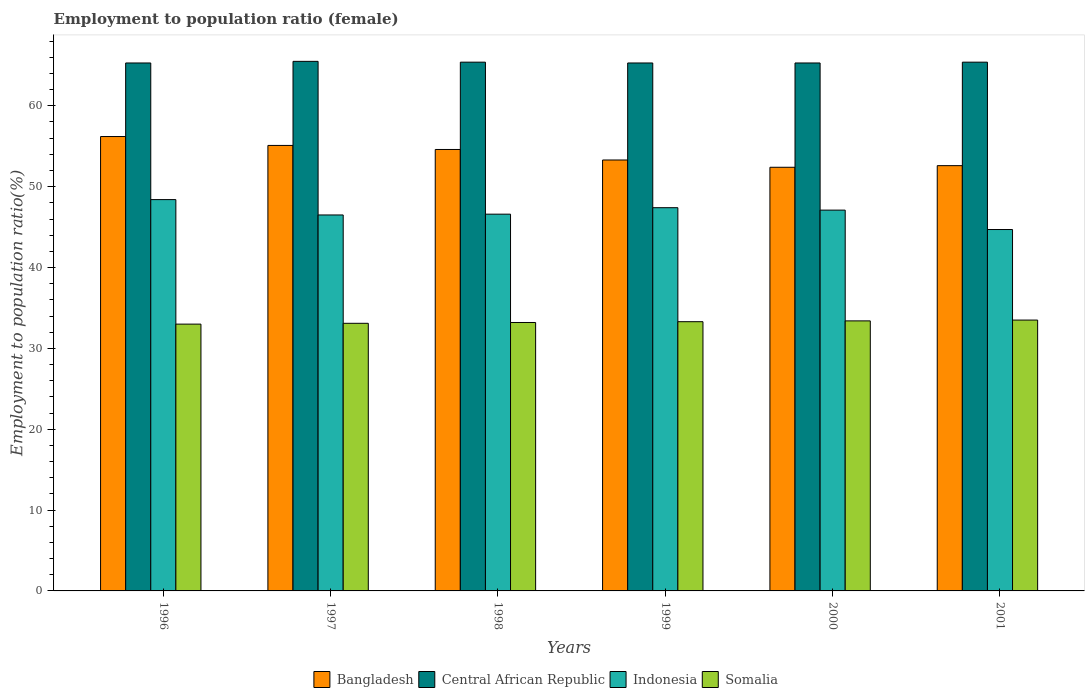How many different coloured bars are there?
Offer a terse response. 4. Are the number of bars on each tick of the X-axis equal?
Make the answer very short. Yes. How many bars are there on the 5th tick from the left?
Provide a succinct answer. 4. What is the employment to population ratio in Indonesia in 1998?
Offer a very short reply. 46.6. Across all years, what is the maximum employment to population ratio in Indonesia?
Offer a very short reply. 48.4. Across all years, what is the minimum employment to population ratio in Indonesia?
Provide a succinct answer. 44.7. In which year was the employment to population ratio in Somalia maximum?
Ensure brevity in your answer.  2001. In which year was the employment to population ratio in Bangladesh minimum?
Ensure brevity in your answer.  2000. What is the total employment to population ratio in Somalia in the graph?
Keep it short and to the point. 199.5. What is the difference between the employment to population ratio in Somalia in 1997 and that in 2000?
Your answer should be very brief. -0.3. What is the difference between the employment to population ratio in Indonesia in 1997 and the employment to population ratio in Bangladesh in 1998?
Keep it short and to the point. -8.1. What is the average employment to population ratio in Central African Republic per year?
Your response must be concise. 65.37. In the year 1997, what is the difference between the employment to population ratio in Bangladesh and employment to population ratio in Central African Republic?
Give a very brief answer. -10.4. What is the ratio of the employment to population ratio in Indonesia in 1998 to that in 2001?
Ensure brevity in your answer.  1.04. Is the employment to population ratio in Somalia in 2000 less than that in 2001?
Keep it short and to the point. Yes. What is the difference between the highest and the second highest employment to population ratio in Bangladesh?
Make the answer very short. 1.1. What is the difference between the highest and the lowest employment to population ratio in Somalia?
Offer a very short reply. 0.5. In how many years, is the employment to population ratio in Central African Republic greater than the average employment to population ratio in Central African Republic taken over all years?
Offer a terse response. 3. Is the sum of the employment to population ratio in Indonesia in 1997 and 1999 greater than the maximum employment to population ratio in Central African Republic across all years?
Offer a very short reply. Yes. What does the 3rd bar from the right in 1998 represents?
Your answer should be very brief. Central African Republic. Is it the case that in every year, the sum of the employment to population ratio in Indonesia and employment to population ratio in Somalia is greater than the employment to population ratio in Bangladesh?
Make the answer very short. Yes. Are all the bars in the graph horizontal?
Ensure brevity in your answer.  No. How many years are there in the graph?
Keep it short and to the point. 6. Where does the legend appear in the graph?
Your answer should be very brief. Bottom center. What is the title of the graph?
Provide a short and direct response. Employment to population ratio (female). Does "Latvia" appear as one of the legend labels in the graph?
Offer a terse response. No. What is the label or title of the Y-axis?
Ensure brevity in your answer.  Employment to population ratio(%). What is the Employment to population ratio(%) in Bangladesh in 1996?
Your response must be concise. 56.2. What is the Employment to population ratio(%) in Central African Republic in 1996?
Your response must be concise. 65.3. What is the Employment to population ratio(%) in Indonesia in 1996?
Provide a short and direct response. 48.4. What is the Employment to population ratio(%) of Somalia in 1996?
Offer a very short reply. 33. What is the Employment to population ratio(%) in Bangladesh in 1997?
Keep it short and to the point. 55.1. What is the Employment to population ratio(%) of Central African Republic in 1997?
Give a very brief answer. 65.5. What is the Employment to population ratio(%) in Indonesia in 1997?
Offer a terse response. 46.5. What is the Employment to population ratio(%) of Somalia in 1997?
Provide a succinct answer. 33.1. What is the Employment to population ratio(%) of Bangladesh in 1998?
Give a very brief answer. 54.6. What is the Employment to population ratio(%) in Central African Republic in 1998?
Make the answer very short. 65.4. What is the Employment to population ratio(%) of Indonesia in 1998?
Your answer should be very brief. 46.6. What is the Employment to population ratio(%) of Somalia in 1998?
Ensure brevity in your answer.  33.2. What is the Employment to population ratio(%) of Bangladesh in 1999?
Your answer should be compact. 53.3. What is the Employment to population ratio(%) in Central African Republic in 1999?
Your answer should be very brief. 65.3. What is the Employment to population ratio(%) of Indonesia in 1999?
Your response must be concise. 47.4. What is the Employment to population ratio(%) of Somalia in 1999?
Your response must be concise. 33.3. What is the Employment to population ratio(%) of Bangladesh in 2000?
Your answer should be compact. 52.4. What is the Employment to population ratio(%) of Central African Republic in 2000?
Provide a succinct answer. 65.3. What is the Employment to population ratio(%) in Indonesia in 2000?
Provide a succinct answer. 47.1. What is the Employment to population ratio(%) of Somalia in 2000?
Your answer should be very brief. 33.4. What is the Employment to population ratio(%) of Bangladesh in 2001?
Keep it short and to the point. 52.6. What is the Employment to population ratio(%) of Central African Republic in 2001?
Make the answer very short. 65.4. What is the Employment to population ratio(%) of Indonesia in 2001?
Your response must be concise. 44.7. What is the Employment to population ratio(%) of Somalia in 2001?
Your response must be concise. 33.5. Across all years, what is the maximum Employment to population ratio(%) of Bangladesh?
Make the answer very short. 56.2. Across all years, what is the maximum Employment to population ratio(%) of Central African Republic?
Your answer should be very brief. 65.5. Across all years, what is the maximum Employment to population ratio(%) in Indonesia?
Make the answer very short. 48.4. Across all years, what is the maximum Employment to population ratio(%) in Somalia?
Keep it short and to the point. 33.5. Across all years, what is the minimum Employment to population ratio(%) in Bangladesh?
Provide a succinct answer. 52.4. Across all years, what is the minimum Employment to population ratio(%) in Central African Republic?
Offer a very short reply. 65.3. Across all years, what is the minimum Employment to population ratio(%) of Indonesia?
Your answer should be very brief. 44.7. Across all years, what is the minimum Employment to population ratio(%) in Somalia?
Offer a terse response. 33. What is the total Employment to population ratio(%) of Bangladesh in the graph?
Offer a very short reply. 324.2. What is the total Employment to population ratio(%) in Central African Republic in the graph?
Make the answer very short. 392.2. What is the total Employment to population ratio(%) in Indonesia in the graph?
Give a very brief answer. 280.7. What is the total Employment to population ratio(%) of Somalia in the graph?
Offer a terse response. 199.5. What is the difference between the Employment to population ratio(%) of Bangladesh in 1996 and that in 1997?
Your answer should be very brief. 1.1. What is the difference between the Employment to population ratio(%) of Central African Republic in 1996 and that in 1997?
Provide a succinct answer. -0.2. What is the difference between the Employment to population ratio(%) in Indonesia in 1996 and that in 1997?
Your response must be concise. 1.9. What is the difference between the Employment to population ratio(%) in Bangladesh in 1996 and that in 1998?
Ensure brevity in your answer.  1.6. What is the difference between the Employment to population ratio(%) of Central African Republic in 1996 and that in 1998?
Give a very brief answer. -0.1. What is the difference between the Employment to population ratio(%) in Somalia in 1996 and that in 1998?
Offer a very short reply. -0.2. What is the difference between the Employment to population ratio(%) of Bangladesh in 1996 and that in 1999?
Offer a very short reply. 2.9. What is the difference between the Employment to population ratio(%) of Central African Republic in 1996 and that in 1999?
Make the answer very short. 0. What is the difference between the Employment to population ratio(%) of Indonesia in 1996 and that in 1999?
Give a very brief answer. 1. What is the difference between the Employment to population ratio(%) in Indonesia in 1996 and that in 2000?
Provide a succinct answer. 1.3. What is the difference between the Employment to population ratio(%) of Bangladesh in 1996 and that in 2001?
Give a very brief answer. 3.6. What is the difference between the Employment to population ratio(%) in Somalia in 1997 and that in 1998?
Keep it short and to the point. -0.1. What is the difference between the Employment to population ratio(%) of Bangladesh in 1997 and that in 1999?
Keep it short and to the point. 1.8. What is the difference between the Employment to population ratio(%) in Central African Republic in 1997 and that in 1999?
Offer a very short reply. 0.2. What is the difference between the Employment to population ratio(%) in Indonesia in 1997 and that in 1999?
Provide a short and direct response. -0.9. What is the difference between the Employment to population ratio(%) in Bangladesh in 1997 and that in 2001?
Your answer should be very brief. 2.5. What is the difference between the Employment to population ratio(%) in Bangladesh in 1998 and that in 1999?
Your answer should be compact. 1.3. What is the difference between the Employment to population ratio(%) of Central African Republic in 1998 and that in 1999?
Ensure brevity in your answer.  0.1. What is the difference between the Employment to population ratio(%) of Somalia in 1998 and that in 1999?
Your answer should be compact. -0.1. What is the difference between the Employment to population ratio(%) of Central African Republic in 1998 and that in 2000?
Your response must be concise. 0.1. What is the difference between the Employment to population ratio(%) in Indonesia in 1998 and that in 2000?
Offer a terse response. -0.5. What is the difference between the Employment to population ratio(%) in Bangladesh in 1998 and that in 2001?
Your response must be concise. 2. What is the difference between the Employment to population ratio(%) in Central African Republic in 1998 and that in 2001?
Provide a succinct answer. 0. What is the difference between the Employment to population ratio(%) of Central African Republic in 1999 and that in 2001?
Your answer should be very brief. -0.1. What is the difference between the Employment to population ratio(%) of Indonesia in 1999 and that in 2001?
Your answer should be very brief. 2.7. What is the difference between the Employment to population ratio(%) of Somalia in 1999 and that in 2001?
Provide a succinct answer. -0.2. What is the difference between the Employment to population ratio(%) of Central African Republic in 2000 and that in 2001?
Your response must be concise. -0.1. What is the difference between the Employment to population ratio(%) in Indonesia in 2000 and that in 2001?
Your response must be concise. 2.4. What is the difference between the Employment to population ratio(%) of Somalia in 2000 and that in 2001?
Your answer should be very brief. -0.1. What is the difference between the Employment to population ratio(%) in Bangladesh in 1996 and the Employment to population ratio(%) in Somalia in 1997?
Offer a very short reply. 23.1. What is the difference between the Employment to population ratio(%) of Central African Republic in 1996 and the Employment to population ratio(%) of Indonesia in 1997?
Give a very brief answer. 18.8. What is the difference between the Employment to population ratio(%) in Central African Republic in 1996 and the Employment to population ratio(%) in Somalia in 1997?
Your answer should be compact. 32.2. What is the difference between the Employment to population ratio(%) in Indonesia in 1996 and the Employment to population ratio(%) in Somalia in 1997?
Keep it short and to the point. 15.3. What is the difference between the Employment to population ratio(%) of Bangladesh in 1996 and the Employment to population ratio(%) of Central African Republic in 1998?
Give a very brief answer. -9.2. What is the difference between the Employment to population ratio(%) in Bangladesh in 1996 and the Employment to population ratio(%) in Indonesia in 1998?
Offer a terse response. 9.6. What is the difference between the Employment to population ratio(%) of Central African Republic in 1996 and the Employment to population ratio(%) of Somalia in 1998?
Your answer should be compact. 32.1. What is the difference between the Employment to population ratio(%) in Indonesia in 1996 and the Employment to population ratio(%) in Somalia in 1998?
Offer a terse response. 15.2. What is the difference between the Employment to population ratio(%) in Bangladesh in 1996 and the Employment to population ratio(%) in Central African Republic in 1999?
Ensure brevity in your answer.  -9.1. What is the difference between the Employment to population ratio(%) in Bangladesh in 1996 and the Employment to population ratio(%) in Indonesia in 1999?
Ensure brevity in your answer.  8.8. What is the difference between the Employment to population ratio(%) of Bangladesh in 1996 and the Employment to population ratio(%) of Somalia in 1999?
Provide a succinct answer. 22.9. What is the difference between the Employment to population ratio(%) in Central African Republic in 1996 and the Employment to population ratio(%) in Indonesia in 1999?
Keep it short and to the point. 17.9. What is the difference between the Employment to population ratio(%) of Bangladesh in 1996 and the Employment to population ratio(%) of Somalia in 2000?
Make the answer very short. 22.8. What is the difference between the Employment to population ratio(%) of Central African Republic in 1996 and the Employment to population ratio(%) of Somalia in 2000?
Provide a short and direct response. 31.9. What is the difference between the Employment to population ratio(%) in Indonesia in 1996 and the Employment to population ratio(%) in Somalia in 2000?
Your answer should be very brief. 15. What is the difference between the Employment to population ratio(%) in Bangladesh in 1996 and the Employment to population ratio(%) in Somalia in 2001?
Give a very brief answer. 22.7. What is the difference between the Employment to population ratio(%) in Central African Republic in 1996 and the Employment to population ratio(%) in Indonesia in 2001?
Provide a succinct answer. 20.6. What is the difference between the Employment to population ratio(%) of Central African Republic in 1996 and the Employment to population ratio(%) of Somalia in 2001?
Offer a very short reply. 31.8. What is the difference between the Employment to population ratio(%) in Indonesia in 1996 and the Employment to population ratio(%) in Somalia in 2001?
Your answer should be very brief. 14.9. What is the difference between the Employment to population ratio(%) of Bangladesh in 1997 and the Employment to population ratio(%) of Central African Republic in 1998?
Make the answer very short. -10.3. What is the difference between the Employment to population ratio(%) of Bangladesh in 1997 and the Employment to population ratio(%) of Somalia in 1998?
Provide a short and direct response. 21.9. What is the difference between the Employment to population ratio(%) in Central African Republic in 1997 and the Employment to population ratio(%) in Indonesia in 1998?
Your answer should be compact. 18.9. What is the difference between the Employment to population ratio(%) in Central African Republic in 1997 and the Employment to population ratio(%) in Somalia in 1998?
Keep it short and to the point. 32.3. What is the difference between the Employment to population ratio(%) of Bangladesh in 1997 and the Employment to population ratio(%) of Indonesia in 1999?
Keep it short and to the point. 7.7. What is the difference between the Employment to population ratio(%) of Bangladesh in 1997 and the Employment to population ratio(%) of Somalia in 1999?
Give a very brief answer. 21.8. What is the difference between the Employment to population ratio(%) in Central African Republic in 1997 and the Employment to population ratio(%) in Somalia in 1999?
Provide a succinct answer. 32.2. What is the difference between the Employment to population ratio(%) of Indonesia in 1997 and the Employment to population ratio(%) of Somalia in 1999?
Give a very brief answer. 13.2. What is the difference between the Employment to population ratio(%) of Bangladesh in 1997 and the Employment to population ratio(%) of Somalia in 2000?
Keep it short and to the point. 21.7. What is the difference between the Employment to population ratio(%) of Central African Republic in 1997 and the Employment to population ratio(%) of Indonesia in 2000?
Offer a very short reply. 18.4. What is the difference between the Employment to population ratio(%) in Central African Republic in 1997 and the Employment to population ratio(%) in Somalia in 2000?
Give a very brief answer. 32.1. What is the difference between the Employment to population ratio(%) of Bangladesh in 1997 and the Employment to population ratio(%) of Central African Republic in 2001?
Give a very brief answer. -10.3. What is the difference between the Employment to population ratio(%) of Bangladesh in 1997 and the Employment to population ratio(%) of Somalia in 2001?
Offer a very short reply. 21.6. What is the difference between the Employment to population ratio(%) of Central African Republic in 1997 and the Employment to population ratio(%) of Indonesia in 2001?
Offer a very short reply. 20.8. What is the difference between the Employment to population ratio(%) in Central African Republic in 1997 and the Employment to population ratio(%) in Somalia in 2001?
Offer a very short reply. 32. What is the difference between the Employment to population ratio(%) of Bangladesh in 1998 and the Employment to population ratio(%) of Central African Republic in 1999?
Your response must be concise. -10.7. What is the difference between the Employment to population ratio(%) in Bangladesh in 1998 and the Employment to population ratio(%) in Indonesia in 1999?
Offer a very short reply. 7.2. What is the difference between the Employment to population ratio(%) in Bangladesh in 1998 and the Employment to population ratio(%) in Somalia in 1999?
Provide a short and direct response. 21.3. What is the difference between the Employment to population ratio(%) of Central African Republic in 1998 and the Employment to population ratio(%) of Indonesia in 1999?
Your response must be concise. 18. What is the difference between the Employment to population ratio(%) of Central African Republic in 1998 and the Employment to population ratio(%) of Somalia in 1999?
Your response must be concise. 32.1. What is the difference between the Employment to population ratio(%) of Indonesia in 1998 and the Employment to population ratio(%) of Somalia in 1999?
Give a very brief answer. 13.3. What is the difference between the Employment to population ratio(%) in Bangladesh in 1998 and the Employment to population ratio(%) in Central African Republic in 2000?
Provide a succinct answer. -10.7. What is the difference between the Employment to population ratio(%) of Bangladesh in 1998 and the Employment to population ratio(%) of Somalia in 2000?
Provide a short and direct response. 21.2. What is the difference between the Employment to population ratio(%) of Central African Republic in 1998 and the Employment to population ratio(%) of Indonesia in 2000?
Provide a succinct answer. 18.3. What is the difference between the Employment to population ratio(%) in Bangladesh in 1998 and the Employment to population ratio(%) in Somalia in 2001?
Your answer should be compact. 21.1. What is the difference between the Employment to population ratio(%) of Central African Republic in 1998 and the Employment to population ratio(%) of Indonesia in 2001?
Ensure brevity in your answer.  20.7. What is the difference between the Employment to population ratio(%) in Central African Republic in 1998 and the Employment to population ratio(%) in Somalia in 2001?
Offer a very short reply. 31.9. What is the difference between the Employment to population ratio(%) of Indonesia in 1998 and the Employment to population ratio(%) of Somalia in 2001?
Provide a short and direct response. 13.1. What is the difference between the Employment to population ratio(%) of Bangladesh in 1999 and the Employment to population ratio(%) of Central African Republic in 2000?
Offer a very short reply. -12. What is the difference between the Employment to population ratio(%) in Central African Republic in 1999 and the Employment to population ratio(%) in Somalia in 2000?
Keep it short and to the point. 31.9. What is the difference between the Employment to population ratio(%) of Indonesia in 1999 and the Employment to population ratio(%) of Somalia in 2000?
Your response must be concise. 14. What is the difference between the Employment to population ratio(%) in Bangladesh in 1999 and the Employment to population ratio(%) in Indonesia in 2001?
Give a very brief answer. 8.6. What is the difference between the Employment to population ratio(%) of Bangladesh in 1999 and the Employment to population ratio(%) of Somalia in 2001?
Keep it short and to the point. 19.8. What is the difference between the Employment to population ratio(%) in Central African Republic in 1999 and the Employment to population ratio(%) in Indonesia in 2001?
Give a very brief answer. 20.6. What is the difference between the Employment to population ratio(%) of Central African Republic in 1999 and the Employment to population ratio(%) of Somalia in 2001?
Offer a very short reply. 31.8. What is the difference between the Employment to population ratio(%) in Indonesia in 1999 and the Employment to population ratio(%) in Somalia in 2001?
Offer a very short reply. 13.9. What is the difference between the Employment to population ratio(%) in Central African Republic in 2000 and the Employment to population ratio(%) in Indonesia in 2001?
Offer a very short reply. 20.6. What is the difference between the Employment to population ratio(%) of Central African Republic in 2000 and the Employment to population ratio(%) of Somalia in 2001?
Give a very brief answer. 31.8. What is the average Employment to population ratio(%) in Bangladesh per year?
Give a very brief answer. 54.03. What is the average Employment to population ratio(%) of Central African Republic per year?
Provide a short and direct response. 65.37. What is the average Employment to population ratio(%) of Indonesia per year?
Provide a short and direct response. 46.78. What is the average Employment to population ratio(%) in Somalia per year?
Make the answer very short. 33.25. In the year 1996, what is the difference between the Employment to population ratio(%) in Bangladesh and Employment to population ratio(%) in Somalia?
Keep it short and to the point. 23.2. In the year 1996, what is the difference between the Employment to population ratio(%) in Central African Republic and Employment to population ratio(%) in Indonesia?
Your response must be concise. 16.9. In the year 1996, what is the difference between the Employment to population ratio(%) of Central African Republic and Employment to population ratio(%) of Somalia?
Give a very brief answer. 32.3. In the year 1997, what is the difference between the Employment to population ratio(%) of Bangladesh and Employment to population ratio(%) of Central African Republic?
Your answer should be compact. -10.4. In the year 1997, what is the difference between the Employment to population ratio(%) in Bangladesh and Employment to population ratio(%) in Indonesia?
Your answer should be very brief. 8.6. In the year 1997, what is the difference between the Employment to population ratio(%) in Bangladesh and Employment to population ratio(%) in Somalia?
Keep it short and to the point. 22. In the year 1997, what is the difference between the Employment to population ratio(%) of Central African Republic and Employment to population ratio(%) of Somalia?
Offer a very short reply. 32.4. In the year 1997, what is the difference between the Employment to population ratio(%) in Indonesia and Employment to population ratio(%) in Somalia?
Ensure brevity in your answer.  13.4. In the year 1998, what is the difference between the Employment to population ratio(%) in Bangladesh and Employment to population ratio(%) in Indonesia?
Give a very brief answer. 8. In the year 1998, what is the difference between the Employment to population ratio(%) of Bangladesh and Employment to population ratio(%) of Somalia?
Give a very brief answer. 21.4. In the year 1998, what is the difference between the Employment to population ratio(%) in Central African Republic and Employment to population ratio(%) in Somalia?
Offer a very short reply. 32.2. In the year 1999, what is the difference between the Employment to population ratio(%) in Bangladesh and Employment to population ratio(%) in Indonesia?
Your answer should be compact. 5.9. In the year 1999, what is the difference between the Employment to population ratio(%) of Bangladesh and Employment to population ratio(%) of Somalia?
Offer a very short reply. 20. In the year 1999, what is the difference between the Employment to population ratio(%) in Central African Republic and Employment to population ratio(%) in Somalia?
Make the answer very short. 32. In the year 2000, what is the difference between the Employment to population ratio(%) in Bangladesh and Employment to population ratio(%) in Central African Republic?
Your answer should be compact. -12.9. In the year 2000, what is the difference between the Employment to population ratio(%) in Bangladesh and Employment to population ratio(%) in Indonesia?
Your answer should be very brief. 5.3. In the year 2000, what is the difference between the Employment to population ratio(%) in Central African Republic and Employment to population ratio(%) in Indonesia?
Offer a very short reply. 18.2. In the year 2000, what is the difference between the Employment to population ratio(%) in Central African Republic and Employment to population ratio(%) in Somalia?
Ensure brevity in your answer.  31.9. In the year 2001, what is the difference between the Employment to population ratio(%) in Bangladesh and Employment to population ratio(%) in Central African Republic?
Your response must be concise. -12.8. In the year 2001, what is the difference between the Employment to population ratio(%) of Central African Republic and Employment to population ratio(%) of Indonesia?
Keep it short and to the point. 20.7. In the year 2001, what is the difference between the Employment to population ratio(%) of Central African Republic and Employment to population ratio(%) of Somalia?
Offer a terse response. 31.9. What is the ratio of the Employment to population ratio(%) of Indonesia in 1996 to that in 1997?
Your answer should be very brief. 1.04. What is the ratio of the Employment to population ratio(%) of Somalia in 1996 to that in 1997?
Provide a succinct answer. 1. What is the ratio of the Employment to population ratio(%) in Bangladesh in 1996 to that in 1998?
Provide a succinct answer. 1.03. What is the ratio of the Employment to population ratio(%) of Indonesia in 1996 to that in 1998?
Provide a succinct answer. 1.04. What is the ratio of the Employment to population ratio(%) of Bangladesh in 1996 to that in 1999?
Your answer should be compact. 1.05. What is the ratio of the Employment to population ratio(%) in Central African Republic in 1996 to that in 1999?
Offer a terse response. 1. What is the ratio of the Employment to population ratio(%) in Indonesia in 1996 to that in 1999?
Offer a very short reply. 1.02. What is the ratio of the Employment to population ratio(%) in Bangladesh in 1996 to that in 2000?
Keep it short and to the point. 1.07. What is the ratio of the Employment to population ratio(%) in Central African Republic in 1996 to that in 2000?
Your answer should be compact. 1. What is the ratio of the Employment to population ratio(%) of Indonesia in 1996 to that in 2000?
Your answer should be compact. 1.03. What is the ratio of the Employment to population ratio(%) in Somalia in 1996 to that in 2000?
Keep it short and to the point. 0.99. What is the ratio of the Employment to population ratio(%) of Bangladesh in 1996 to that in 2001?
Your response must be concise. 1.07. What is the ratio of the Employment to population ratio(%) in Central African Republic in 1996 to that in 2001?
Keep it short and to the point. 1. What is the ratio of the Employment to population ratio(%) in Indonesia in 1996 to that in 2001?
Ensure brevity in your answer.  1.08. What is the ratio of the Employment to population ratio(%) in Somalia in 1996 to that in 2001?
Make the answer very short. 0.99. What is the ratio of the Employment to population ratio(%) in Bangladesh in 1997 to that in 1998?
Ensure brevity in your answer.  1.01. What is the ratio of the Employment to population ratio(%) of Indonesia in 1997 to that in 1998?
Make the answer very short. 1. What is the ratio of the Employment to population ratio(%) in Somalia in 1997 to that in 1998?
Give a very brief answer. 1. What is the ratio of the Employment to population ratio(%) of Bangladesh in 1997 to that in 1999?
Provide a short and direct response. 1.03. What is the ratio of the Employment to population ratio(%) in Central African Republic in 1997 to that in 1999?
Give a very brief answer. 1. What is the ratio of the Employment to population ratio(%) of Somalia in 1997 to that in 1999?
Give a very brief answer. 0.99. What is the ratio of the Employment to population ratio(%) of Bangladesh in 1997 to that in 2000?
Give a very brief answer. 1.05. What is the ratio of the Employment to population ratio(%) in Central African Republic in 1997 to that in 2000?
Provide a succinct answer. 1. What is the ratio of the Employment to population ratio(%) of Indonesia in 1997 to that in 2000?
Your answer should be very brief. 0.99. What is the ratio of the Employment to population ratio(%) of Bangladesh in 1997 to that in 2001?
Ensure brevity in your answer.  1.05. What is the ratio of the Employment to population ratio(%) of Indonesia in 1997 to that in 2001?
Your response must be concise. 1.04. What is the ratio of the Employment to population ratio(%) of Somalia in 1997 to that in 2001?
Ensure brevity in your answer.  0.99. What is the ratio of the Employment to population ratio(%) of Bangladesh in 1998 to that in 1999?
Offer a terse response. 1.02. What is the ratio of the Employment to population ratio(%) in Indonesia in 1998 to that in 1999?
Your answer should be very brief. 0.98. What is the ratio of the Employment to population ratio(%) of Somalia in 1998 to that in 1999?
Your response must be concise. 1. What is the ratio of the Employment to population ratio(%) of Bangladesh in 1998 to that in 2000?
Offer a terse response. 1.04. What is the ratio of the Employment to population ratio(%) of Indonesia in 1998 to that in 2000?
Your response must be concise. 0.99. What is the ratio of the Employment to population ratio(%) in Bangladesh in 1998 to that in 2001?
Your answer should be compact. 1.04. What is the ratio of the Employment to population ratio(%) in Indonesia in 1998 to that in 2001?
Make the answer very short. 1.04. What is the ratio of the Employment to population ratio(%) of Somalia in 1998 to that in 2001?
Offer a terse response. 0.99. What is the ratio of the Employment to population ratio(%) of Bangladesh in 1999 to that in 2000?
Your response must be concise. 1.02. What is the ratio of the Employment to population ratio(%) in Central African Republic in 1999 to that in 2000?
Your response must be concise. 1. What is the ratio of the Employment to population ratio(%) of Indonesia in 1999 to that in 2000?
Offer a very short reply. 1.01. What is the ratio of the Employment to population ratio(%) of Somalia in 1999 to that in 2000?
Offer a terse response. 1. What is the ratio of the Employment to population ratio(%) of Bangladesh in 1999 to that in 2001?
Provide a short and direct response. 1.01. What is the ratio of the Employment to population ratio(%) of Indonesia in 1999 to that in 2001?
Your answer should be very brief. 1.06. What is the ratio of the Employment to population ratio(%) in Somalia in 1999 to that in 2001?
Your response must be concise. 0.99. What is the ratio of the Employment to population ratio(%) of Central African Republic in 2000 to that in 2001?
Ensure brevity in your answer.  1. What is the ratio of the Employment to population ratio(%) of Indonesia in 2000 to that in 2001?
Offer a very short reply. 1.05. What is the difference between the highest and the second highest Employment to population ratio(%) in Bangladesh?
Your answer should be very brief. 1.1. What is the difference between the highest and the lowest Employment to population ratio(%) in Bangladesh?
Your answer should be compact. 3.8. What is the difference between the highest and the lowest Employment to population ratio(%) in Central African Republic?
Provide a succinct answer. 0.2. What is the difference between the highest and the lowest Employment to population ratio(%) in Indonesia?
Offer a terse response. 3.7. What is the difference between the highest and the lowest Employment to population ratio(%) in Somalia?
Provide a short and direct response. 0.5. 